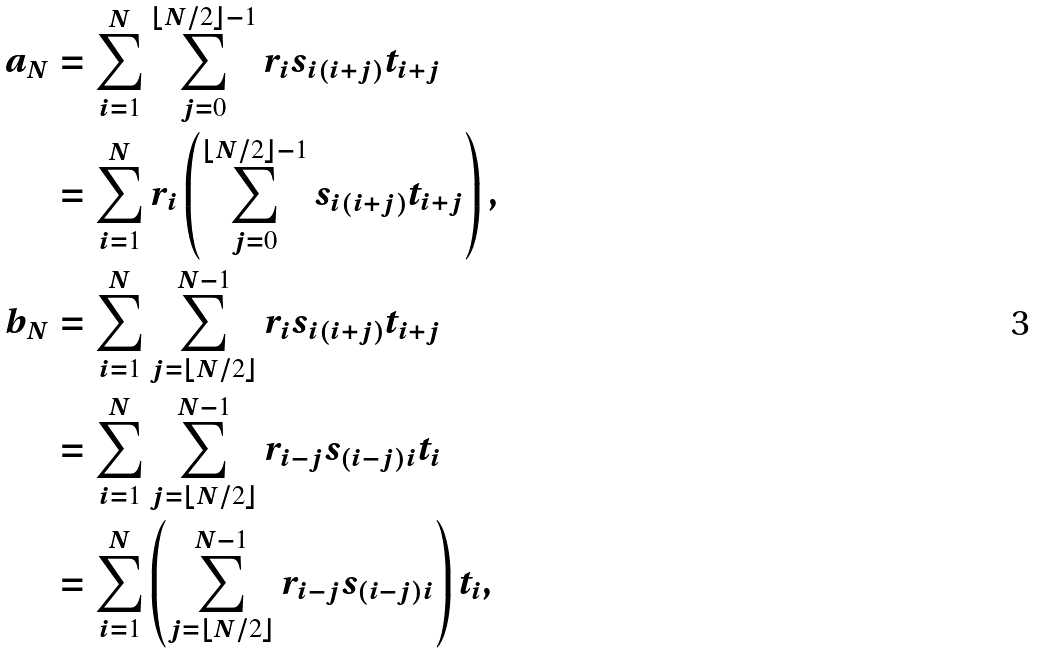Convert formula to latex. <formula><loc_0><loc_0><loc_500><loc_500>a _ { N } & = \sum _ { i = 1 } ^ { N } \sum _ { j = 0 } ^ { \lfloor N / 2 \rfloor - 1 } r _ { i } s _ { i ( i + j ) } t _ { i + j } \\ & = \sum _ { i = 1 } ^ { N } r _ { i } \left ( \sum _ { j = 0 } ^ { \lfloor N / 2 \rfloor - 1 } s _ { i ( i + j ) } t _ { i + j } \right ) , \\ b _ { N } & = \sum _ { i = 1 } ^ { N } \sum _ { j = \lfloor N / 2 \rfloor } ^ { N - 1 } r _ { i } s _ { i ( i + j ) } t _ { i + j } \\ & = \sum _ { i = 1 } ^ { N } \sum _ { j = \lfloor N / 2 \rfloor } ^ { N - 1 } r _ { i - j } s _ { ( i - j ) i } t _ { i } \\ & = \sum _ { i = 1 } ^ { N } \left ( \sum _ { j = \lfloor N / 2 \rfloor } ^ { N - 1 } r _ { i - j } s _ { ( i - j ) i } \right ) t _ { i } ,</formula> 